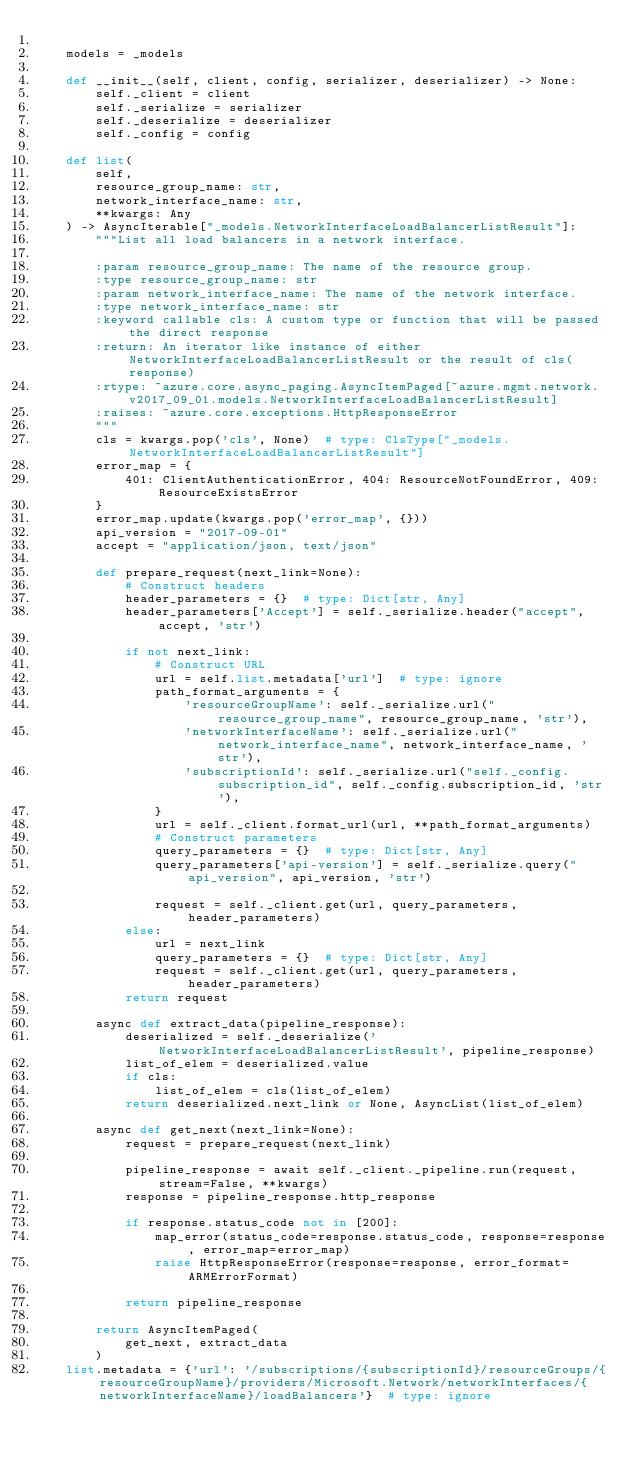Convert code to text. <code><loc_0><loc_0><loc_500><loc_500><_Python_>
    models = _models

    def __init__(self, client, config, serializer, deserializer) -> None:
        self._client = client
        self._serialize = serializer
        self._deserialize = deserializer
        self._config = config

    def list(
        self,
        resource_group_name: str,
        network_interface_name: str,
        **kwargs: Any
    ) -> AsyncIterable["_models.NetworkInterfaceLoadBalancerListResult"]:
        """List all load balancers in a network interface.

        :param resource_group_name: The name of the resource group.
        :type resource_group_name: str
        :param network_interface_name: The name of the network interface.
        :type network_interface_name: str
        :keyword callable cls: A custom type or function that will be passed the direct response
        :return: An iterator like instance of either NetworkInterfaceLoadBalancerListResult or the result of cls(response)
        :rtype: ~azure.core.async_paging.AsyncItemPaged[~azure.mgmt.network.v2017_09_01.models.NetworkInterfaceLoadBalancerListResult]
        :raises: ~azure.core.exceptions.HttpResponseError
        """
        cls = kwargs.pop('cls', None)  # type: ClsType["_models.NetworkInterfaceLoadBalancerListResult"]
        error_map = {
            401: ClientAuthenticationError, 404: ResourceNotFoundError, 409: ResourceExistsError
        }
        error_map.update(kwargs.pop('error_map', {}))
        api_version = "2017-09-01"
        accept = "application/json, text/json"

        def prepare_request(next_link=None):
            # Construct headers
            header_parameters = {}  # type: Dict[str, Any]
            header_parameters['Accept'] = self._serialize.header("accept", accept, 'str')

            if not next_link:
                # Construct URL
                url = self.list.metadata['url']  # type: ignore
                path_format_arguments = {
                    'resourceGroupName': self._serialize.url("resource_group_name", resource_group_name, 'str'),
                    'networkInterfaceName': self._serialize.url("network_interface_name", network_interface_name, 'str'),
                    'subscriptionId': self._serialize.url("self._config.subscription_id", self._config.subscription_id, 'str'),
                }
                url = self._client.format_url(url, **path_format_arguments)
                # Construct parameters
                query_parameters = {}  # type: Dict[str, Any]
                query_parameters['api-version'] = self._serialize.query("api_version", api_version, 'str')

                request = self._client.get(url, query_parameters, header_parameters)
            else:
                url = next_link
                query_parameters = {}  # type: Dict[str, Any]
                request = self._client.get(url, query_parameters, header_parameters)
            return request

        async def extract_data(pipeline_response):
            deserialized = self._deserialize('NetworkInterfaceLoadBalancerListResult', pipeline_response)
            list_of_elem = deserialized.value
            if cls:
                list_of_elem = cls(list_of_elem)
            return deserialized.next_link or None, AsyncList(list_of_elem)

        async def get_next(next_link=None):
            request = prepare_request(next_link)

            pipeline_response = await self._client._pipeline.run(request, stream=False, **kwargs)
            response = pipeline_response.http_response

            if response.status_code not in [200]:
                map_error(status_code=response.status_code, response=response, error_map=error_map)
                raise HttpResponseError(response=response, error_format=ARMErrorFormat)

            return pipeline_response

        return AsyncItemPaged(
            get_next, extract_data
        )
    list.metadata = {'url': '/subscriptions/{subscriptionId}/resourceGroups/{resourceGroupName}/providers/Microsoft.Network/networkInterfaces/{networkInterfaceName}/loadBalancers'}  # type: ignore
</code> 